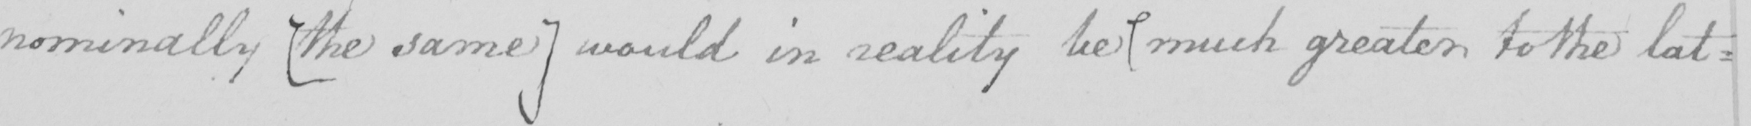Please provide the text content of this handwritten line. nominally  [ the same  ]  would in reality be much greater to the lat : 